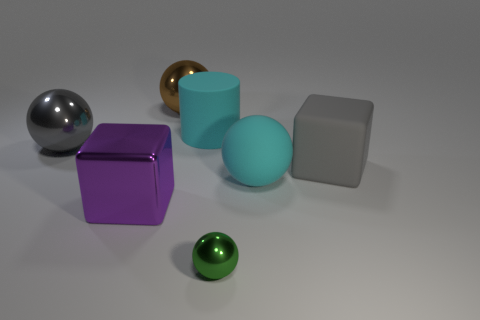Add 2 tiny things. How many objects exist? 9 Subtract all cylinders. How many objects are left? 6 Add 1 cyan rubber cylinders. How many cyan rubber cylinders exist? 2 Subtract 0 yellow blocks. How many objects are left? 7 Subtract all gray cubes. Subtract all big gray metal balls. How many objects are left? 5 Add 4 gray shiny balls. How many gray shiny balls are left? 5 